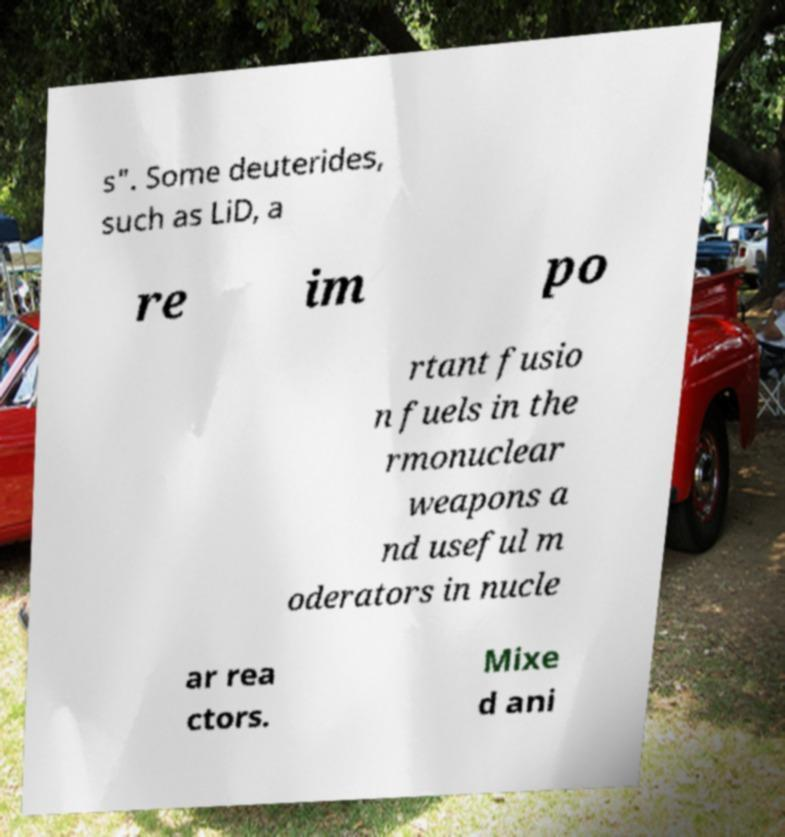I need the written content from this picture converted into text. Can you do that? s". Some deuterides, such as LiD, a re im po rtant fusio n fuels in the rmonuclear weapons a nd useful m oderators in nucle ar rea ctors. Mixe d ani 